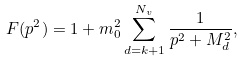Convert formula to latex. <formula><loc_0><loc_0><loc_500><loc_500>F ( p ^ { 2 } ) = 1 + m _ { 0 } ^ { 2 } \sum _ { d = k + 1 } ^ { N _ { v } } \frac { 1 } { p ^ { 2 } + M _ { d } ^ { 2 } } ,</formula> 